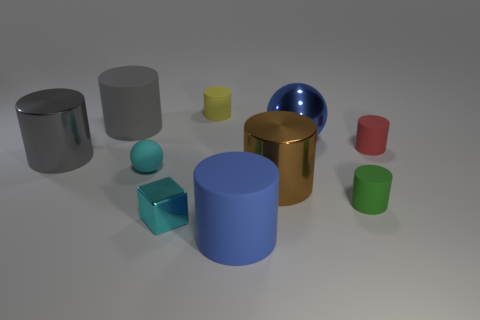Subtract all gray cylinders. How many cylinders are left? 5 Subtract all brown cubes. How many gray cylinders are left? 2 Subtract all green cylinders. How many cylinders are left? 6 Subtract 5 cylinders. How many cylinders are left? 2 Subtract all cubes. How many objects are left? 9 Subtract all gray cylinders. Subtract all brown balls. How many cylinders are left? 5 Subtract all small cyan rubber objects. Subtract all cyan metallic things. How many objects are left? 8 Add 1 tiny spheres. How many tiny spheres are left? 2 Add 4 large yellow cylinders. How many large yellow cylinders exist? 4 Subtract 0 yellow blocks. How many objects are left? 10 